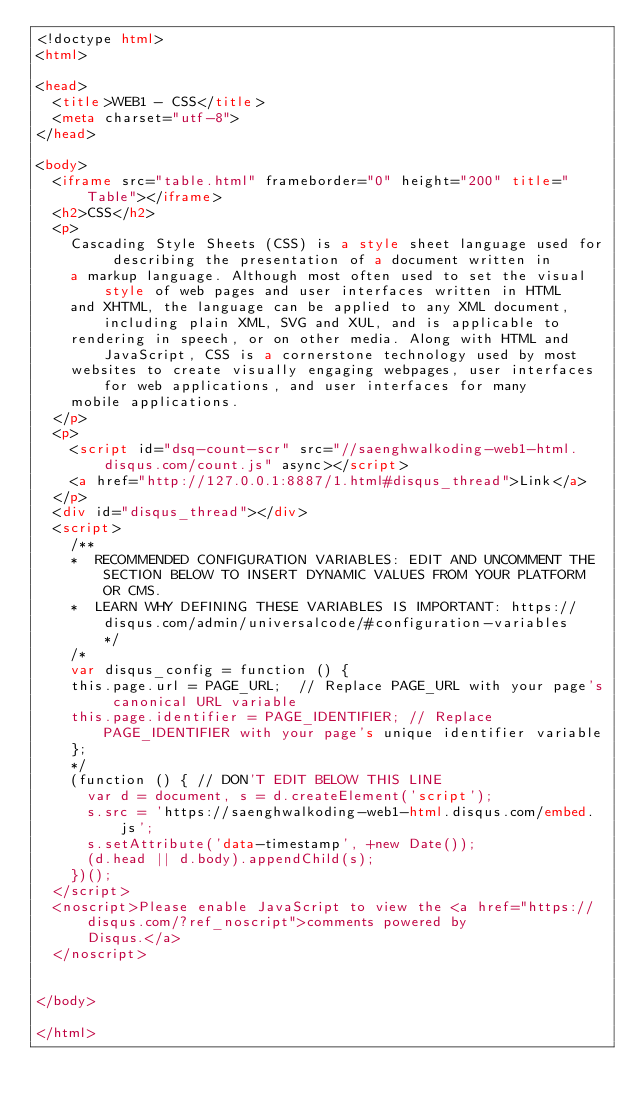Convert code to text. <code><loc_0><loc_0><loc_500><loc_500><_HTML_><!doctype html>
<html>

<head>
  <title>WEB1 - CSS</title>
  <meta charset="utf-8">
</head>

<body>
  <iframe src="table.html" frameborder="0" height="200" title="Table"></iframe>
  <h2>CSS</h2>
  <p>
    Cascading Style Sheets (CSS) is a style sheet language used for describing the presentation of a document written in
    a markup language. Although most often used to set the visual style of web pages and user interfaces written in HTML
    and XHTML, the language can be applied to any XML document, including plain XML, SVG and XUL, and is applicable to
    rendering in speech, or on other media. Along with HTML and JavaScript, CSS is a cornerstone technology used by most
    websites to create visually engaging webpages, user interfaces for web applications, and user interfaces for many
    mobile applications.
  </p>
  <p>
    <script id="dsq-count-scr" src="//saenghwalkoding-web1-html.disqus.com/count.js" async></script>
    <a href="http://127.0.0.1:8887/1.html#disqus_thread">Link</a>
  </p>
  <div id="disqus_thread"></div>
  <script>
    /**
    *  RECOMMENDED CONFIGURATION VARIABLES: EDIT AND UNCOMMENT THE SECTION BELOW TO INSERT DYNAMIC VALUES FROM YOUR PLATFORM OR CMS.
    *  LEARN WHY DEFINING THESE VARIABLES IS IMPORTANT: https://disqus.com/admin/universalcode/#configuration-variables    */
    /*
    var disqus_config = function () {
    this.page.url = PAGE_URL;  // Replace PAGE_URL with your page's canonical URL variable
    this.page.identifier = PAGE_IDENTIFIER; // Replace PAGE_IDENTIFIER with your page's unique identifier variable
    };
    */
    (function () { // DON'T EDIT BELOW THIS LINE
      var d = document, s = d.createElement('script');
      s.src = 'https://saenghwalkoding-web1-html.disqus.com/embed.js';
      s.setAttribute('data-timestamp', +new Date());
      (d.head || d.body).appendChild(s);
    })();
  </script>
  <noscript>Please enable JavaScript to view the <a href="https://disqus.com/?ref_noscript">comments powered by
      Disqus.</a>
  </noscript>


</body>

</html></code> 